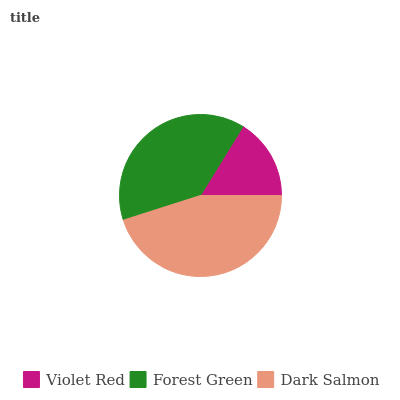Is Violet Red the minimum?
Answer yes or no. Yes. Is Dark Salmon the maximum?
Answer yes or no. Yes. Is Forest Green the minimum?
Answer yes or no. No. Is Forest Green the maximum?
Answer yes or no. No. Is Forest Green greater than Violet Red?
Answer yes or no. Yes. Is Violet Red less than Forest Green?
Answer yes or no. Yes. Is Violet Red greater than Forest Green?
Answer yes or no. No. Is Forest Green less than Violet Red?
Answer yes or no. No. Is Forest Green the high median?
Answer yes or no. Yes. Is Forest Green the low median?
Answer yes or no. Yes. Is Dark Salmon the high median?
Answer yes or no. No. Is Dark Salmon the low median?
Answer yes or no. No. 